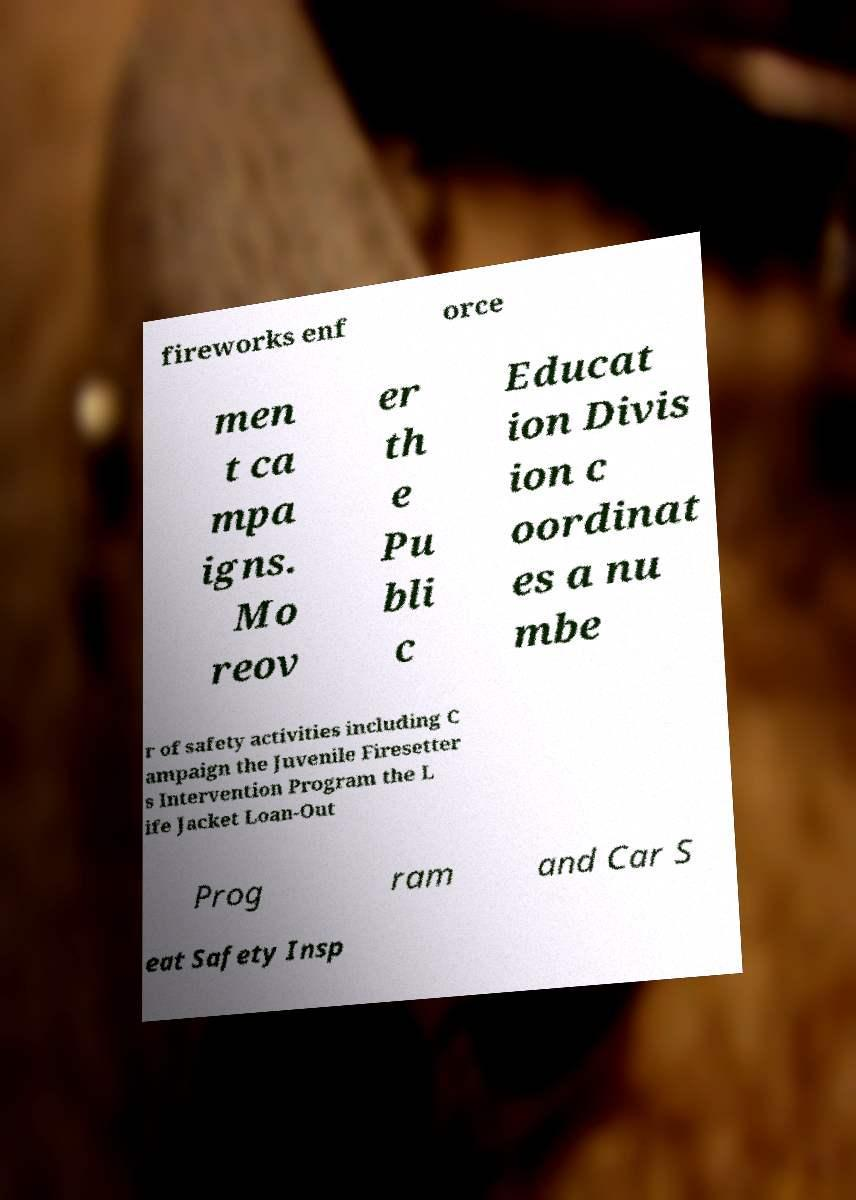I need the written content from this picture converted into text. Can you do that? fireworks enf orce men t ca mpa igns. Mo reov er th e Pu bli c Educat ion Divis ion c oordinat es a nu mbe r of safety activities including C ampaign the Juvenile Firesetter s Intervention Program the L ife Jacket Loan-Out Prog ram and Car S eat Safety Insp 